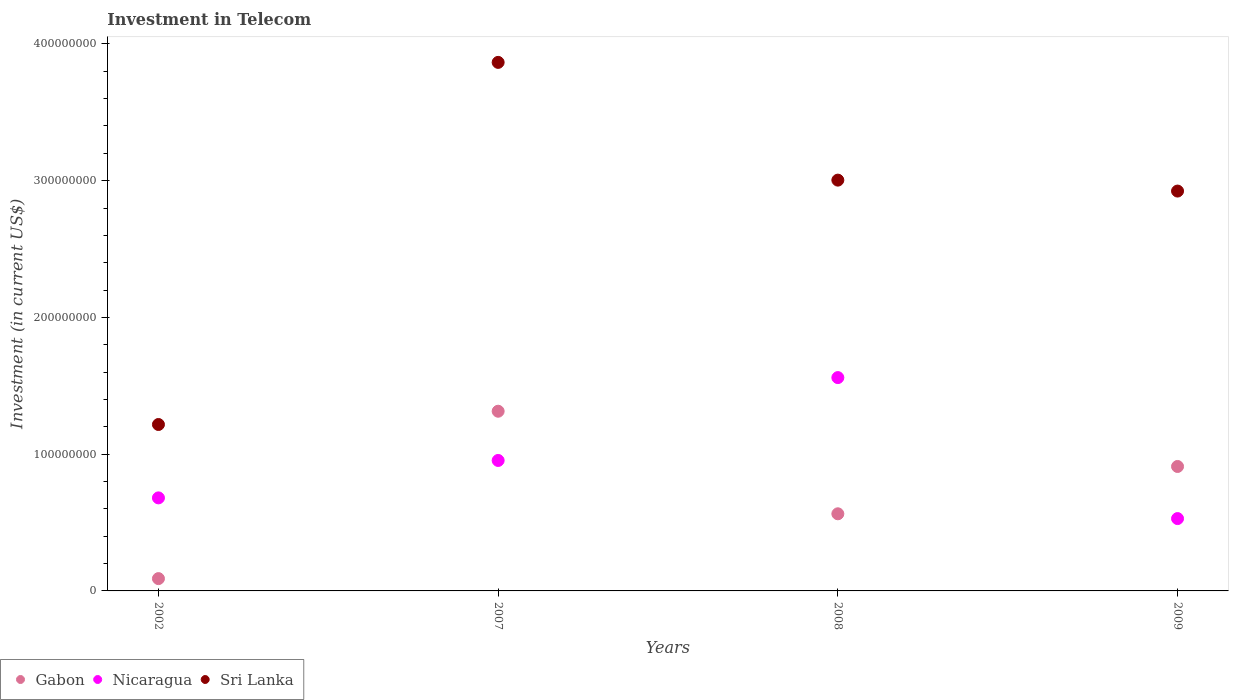How many different coloured dotlines are there?
Give a very brief answer. 3. Is the number of dotlines equal to the number of legend labels?
Your response must be concise. Yes. What is the amount invested in telecom in Gabon in 2009?
Provide a short and direct response. 9.10e+07. Across all years, what is the maximum amount invested in telecom in Sri Lanka?
Give a very brief answer. 3.86e+08. Across all years, what is the minimum amount invested in telecom in Gabon?
Your answer should be very brief. 9.00e+06. In which year was the amount invested in telecom in Sri Lanka maximum?
Offer a terse response. 2007. In which year was the amount invested in telecom in Nicaragua minimum?
Your answer should be very brief. 2009. What is the total amount invested in telecom in Sri Lanka in the graph?
Give a very brief answer. 1.10e+09. What is the difference between the amount invested in telecom in Nicaragua in 2008 and that in 2009?
Provide a succinct answer. 1.03e+08. What is the difference between the amount invested in telecom in Sri Lanka in 2007 and the amount invested in telecom in Gabon in 2008?
Keep it short and to the point. 3.30e+08. What is the average amount invested in telecom in Gabon per year?
Provide a short and direct response. 7.20e+07. In the year 2007, what is the difference between the amount invested in telecom in Gabon and amount invested in telecom in Sri Lanka?
Keep it short and to the point. -2.55e+08. What is the ratio of the amount invested in telecom in Nicaragua in 2002 to that in 2009?
Your response must be concise. 1.29. Is the amount invested in telecom in Nicaragua in 2007 less than that in 2009?
Your response must be concise. No. What is the difference between the highest and the second highest amount invested in telecom in Sri Lanka?
Offer a very short reply. 8.61e+07. What is the difference between the highest and the lowest amount invested in telecom in Sri Lanka?
Your answer should be compact. 2.65e+08. In how many years, is the amount invested in telecom in Gabon greater than the average amount invested in telecom in Gabon taken over all years?
Offer a very short reply. 2. Is the sum of the amount invested in telecom in Sri Lanka in 2002 and 2008 greater than the maximum amount invested in telecom in Nicaragua across all years?
Provide a short and direct response. Yes. Is the amount invested in telecom in Nicaragua strictly greater than the amount invested in telecom in Sri Lanka over the years?
Ensure brevity in your answer.  No. Is the amount invested in telecom in Nicaragua strictly less than the amount invested in telecom in Sri Lanka over the years?
Your answer should be compact. Yes. How many dotlines are there?
Make the answer very short. 3. How many years are there in the graph?
Give a very brief answer. 4. What is the difference between two consecutive major ticks on the Y-axis?
Make the answer very short. 1.00e+08. Where does the legend appear in the graph?
Offer a terse response. Bottom left. What is the title of the graph?
Offer a very short reply. Investment in Telecom. Does "Hungary" appear as one of the legend labels in the graph?
Your answer should be very brief. No. What is the label or title of the X-axis?
Your response must be concise. Years. What is the label or title of the Y-axis?
Ensure brevity in your answer.  Investment (in current US$). What is the Investment (in current US$) of Gabon in 2002?
Give a very brief answer. 9.00e+06. What is the Investment (in current US$) of Nicaragua in 2002?
Provide a succinct answer. 6.80e+07. What is the Investment (in current US$) in Sri Lanka in 2002?
Ensure brevity in your answer.  1.22e+08. What is the Investment (in current US$) of Gabon in 2007?
Keep it short and to the point. 1.31e+08. What is the Investment (in current US$) of Nicaragua in 2007?
Provide a short and direct response. 9.54e+07. What is the Investment (in current US$) of Sri Lanka in 2007?
Keep it short and to the point. 3.86e+08. What is the Investment (in current US$) in Gabon in 2008?
Provide a succinct answer. 5.64e+07. What is the Investment (in current US$) in Nicaragua in 2008?
Your response must be concise. 1.56e+08. What is the Investment (in current US$) in Sri Lanka in 2008?
Make the answer very short. 3.00e+08. What is the Investment (in current US$) of Gabon in 2009?
Keep it short and to the point. 9.10e+07. What is the Investment (in current US$) of Nicaragua in 2009?
Provide a short and direct response. 5.29e+07. What is the Investment (in current US$) of Sri Lanka in 2009?
Your answer should be very brief. 2.92e+08. Across all years, what is the maximum Investment (in current US$) in Gabon?
Make the answer very short. 1.31e+08. Across all years, what is the maximum Investment (in current US$) of Nicaragua?
Give a very brief answer. 1.56e+08. Across all years, what is the maximum Investment (in current US$) of Sri Lanka?
Keep it short and to the point. 3.86e+08. Across all years, what is the minimum Investment (in current US$) in Gabon?
Provide a short and direct response. 9.00e+06. Across all years, what is the minimum Investment (in current US$) in Nicaragua?
Ensure brevity in your answer.  5.29e+07. Across all years, what is the minimum Investment (in current US$) in Sri Lanka?
Your answer should be very brief. 1.22e+08. What is the total Investment (in current US$) of Gabon in the graph?
Provide a short and direct response. 2.88e+08. What is the total Investment (in current US$) of Nicaragua in the graph?
Offer a very short reply. 3.72e+08. What is the total Investment (in current US$) in Sri Lanka in the graph?
Give a very brief answer. 1.10e+09. What is the difference between the Investment (in current US$) in Gabon in 2002 and that in 2007?
Provide a short and direct response. -1.22e+08. What is the difference between the Investment (in current US$) of Nicaragua in 2002 and that in 2007?
Ensure brevity in your answer.  -2.74e+07. What is the difference between the Investment (in current US$) of Sri Lanka in 2002 and that in 2007?
Your answer should be very brief. -2.65e+08. What is the difference between the Investment (in current US$) in Gabon in 2002 and that in 2008?
Your answer should be very brief. -4.74e+07. What is the difference between the Investment (in current US$) of Nicaragua in 2002 and that in 2008?
Ensure brevity in your answer.  -8.80e+07. What is the difference between the Investment (in current US$) in Sri Lanka in 2002 and that in 2008?
Make the answer very short. -1.79e+08. What is the difference between the Investment (in current US$) of Gabon in 2002 and that in 2009?
Your answer should be compact. -8.20e+07. What is the difference between the Investment (in current US$) of Nicaragua in 2002 and that in 2009?
Your answer should be very brief. 1.51e+07. What is the difference between the Investment (in current US$) in Sri Lanka in 2002 and that in 2009?
Your answer should be compact. -1.71e+08. What is the difference between the Investment (in current US$) of Gabon in 2007 and that in 2008?
Offer a very short reply. 7.50e+07. What is the difference between the Investment (in current US$) in Nicaragua in 2007 and that in 2008?
Offer a terse response. -6.06e+07. What is the difference between the Investment (in current US$) in Sri Lanka in 2007 and that in 2008?
Keep it short and to the point. 8.61e+07. What is the difference between the Investment (in current US$) in Gabon in 2007 and that in 2009?
Offer a very short reply. 4.04e+07. What is the difference between the Investment (in current US$) of Nicaragua in 2007 and that in 2009?
Offer a very short reply. 4.25e+07. What is the difference between the Investment (in current US$) of Sri Lanka in 2007 and that in 2009?
Provide a succinct answer. 9.41e+07. What is the difference between the Investment (in current US$) in Gabon in 2008 and that in 2009?
Provide a succinct answer. -3.46e+07. What is the difference between the Investment (in current US$) of Nicaragua in 2008 and that in 2009?
Make the answer very short. 1.03e+08. What is the difference between the Investment (in current US$) in Sri Lanka in 2008 and that in 2009?
Your answer should be very brief. 8.00e+06. What is the difference between the Investment (in current US$) in Gabon in 2002 and the Investment (in current US$) in Nicaragua in 2007?
Offer a very short reply. -8.64e+07. What is the difference between the Investment (in current US$) in Gabon in 2002 and the Investment (in current US$) in Sri Lanka in 2007?
Ensure brevity in your answer.  -3.78e+08. What is the difference between the Investment (in current US$) of Nicaragua in 2002 and the Investment (in current US$) of Sri Lanka in 2007?
Offer a very short reply. -3.18e+08. What is the difference between the Investment (in current US$) in Gabon in 2002 and the Investment (in current US$) in Nicaragua in 2008?
Give a very brief answer. -1.47e+08. What is the difference between the Investment (in current US$) of Gabon in 2002 and the Investment (in current US$) of Sri Lanka in 2008?
Your answer should be very brief. -2.91e+08. What is the difference between the Investment (in current US$) of Nicaragua in 2002 and the Investment (in current US$) of Sri Lanka in 2008?
Provide a succinct answer. -2.32e+08. What is the difference between the Investment (in current US$) in Gabon in 2002 and the Investment (in current US$) in Nicaragua in 2009?
Ensure brevity in your answer.  -4.39e+07. What is the difference between the Investment (in current US$) of Gabon in 2002 and the Investment (in current US$) of Sri Lanka in 2009?
Provide a short and direct response. -2.83e+08. What is the difference between the Investment (in current US$) in Nicaragua in 2002 and the Investment (in current US$) in Sri Lanka in 2009?
Keep it short and to the point. -2.24e+08. What is the difference between the Investment (in current US$) of Gabon in 2007 and the Investment (in current US$) of Nicaragua in 2008?
Your response must be concise. -2.46e+07. What is the difference between the Investment (in current US$) in Gabon in 2007 and the Investment (in current US$) in Sri Lanka in 2008?
Keep it short and to the point. -1.69e+08. What is the difference between the Investment (in current US$) in Nicaragua in 2007 and the Investment (in current US$) in Sri Lanka in 2008?
Your response must be concise. -2.05e+08. What is the difference between the Investment (in current US$) of Gabon in 2007 and the Investment (in current US$) of Nicaragua in 2009?
Your response must be concise. 7.85e+07. What is the difference between the Investment (in current US$) of Gabon in 2007 and the Investment (in current US$) of Sri Lanka in 2009?
Make the answer very short. -1.61e+08. What is the difference between the Investment (in current US$) in Nicaragua in 2007 and the Investment (in current US$) in Sri Lanka in 2009?
Your answer should be compact. -1.97e+08. What is the difference between the Investment (in current US$) of Gabon in 2008 and the Investment (in current US$) of Nicaragua in 2009?
Offer a very short reply. 3.50e+06. What is the difference between the Investment (in current US$) of Gabon in 2008 and the Investment (in current US$) of Sri Lanka in 2009?
Offer a very short reply. -2.36e+08. What is the difference between the Investment (in current US$) in Nicaragua in 2008 and the Investment (in current US$) in Sri Lanka in 2009?
Offer a terse response. -1.36e+08. What is the average Investment (in current US$) of Gabon per year?
Offer a terse response. 7.20e+07. What is the average Investment (in current US$) in Nicaragua per year?
Give a very brief answer. 9.31e+07. What is the average Investment (in current US$) of Sri Lanka per year?
Your answer should be very brief. 2.75e+08. In the year 2002, what is the difference between the Investment (in current US$) of Gabon and Investment (in current US$) of Nicaragua?
Your response must be concise. -5.90e+07. In the year 2002, what is the difference between the Investment (in current US$) in Gabon and Investment (in current US$) in Sri Lanka?
Your answer should be compact. -1.13e+08. In the year 2002, what is the difference between the Investment (in current US$) of Nicaragua and Investment (in current US$) of Sri Lanka?
Ensure brevity in your answer.  -5.37e+07. In the year 2007, what is the difference between the Investment (in current US$) in Gabon and Investment (in current US$) in Nicaragua?
Your response must be concise. 3.60e+07. In the year 2007, what is the difference between the Investment (in current US$) of Gabon and Investment (in current US$) of Sri Lanka?
Offer a terse response. -2.55e+08. In the year 2007, what is the difference between the Investment (in current US$) in Nicaragua and Investment (in current US$) in Sri Lanka?
Offer a very short reply. -2.91e+08. In the year 2008, what is the difference between the Investment (in current US$) in Gabon and Investment (in current US$) in Nicaragua?
Provide a short and direct response. -9.96e+07. In the year 2008, what is the difference between the Investment (in current US$) of Gabon and Investment (in current US$) of Sri Lanka?
Give a very brief answer. -2.44e+08. In the year 2008, what is the difference between the Investment (in current US$) of Nicaragua and Investment (in current US$) of Sri Lanka?
Make the answer very short. -1.44e+08. In the year 2009, what is the difference between the Investment (in current US$) in Gabon and Investment (in current US$) in Nicaragua?
Ensure brevity in your answer.  3.81e+07. In the year 2009, what is the difference between the Investment (in current US$) of Gabon and Investment (in current US$) of Sri Lanka?
Provide a succinct answer. -2.01e+08. In the year 2009, what is the difference between the Investment (in current US$) in Nicaragua and Investment (in current US$) in Sri Lanka?
Offer a very short reply. -2.40e+08. What is the ratio of the Investment (in current US$) of Gabon in 2002 to that in 2007?
Offer a terse response. 0.07. What is the ratio of the Investment (in current US$) in Nicaragua in 2002 to that in 2007?
Your answer should be very brief. 0.71. What is the ratio of the Investment (in current US$) in Sri Lanka in 2002 to that in 2007?
Your answer should be very brief. 0.31. What is the ratio of the Investment (in current US$) of Gabon in 2002 to that in 2008?
Make the answer very short. 0.16. What is the ratio of the Investment (in current US$) in Nicaragua in 2002 to that in 2008?
Your response must be concise. 0.44. What is the ratio of the Investment (in current US$) of Sri Lanka in 2002 to that in 2008?
Your answer should be very brief. 0.41. What is the ratio of the Investment (in current US$) of Gabon in 2002 to that in 2009?
Offer a terse response. 0.1. What is the ratio of the Investment (in current US$) of Nicaragua in 2002 to that in 2009?
Make the answer very short. 1.29. What is the ratio of the Investment (in current US$) of Sri Lanka in 2002 to that in 2009?
Keep it short and to the point. 0.42. What is the ratio of the Investment (in current US$) in Gabon in 2007 to that in 2008?
Keep it short and to the point. 2.33. What is the ratio of the Investment (in current US$) in Nicaragua in 2007 to that in 2008?
Your response must be concise. 0.61. What is the ratio of the Investment (in current US$) in Sri Lanka in 2007 to that in 2008?
Your answer should be compact. 1.29. What is the ratio of the Investment (in current US$) in Gabon in 2007 to that in 2009?
Your response must be concise. 1.44. What is the ratio of the Investment (in current US$) of Nicaragua in 2007 to that in 2009?
Make the answer very short. 1.8. What is the ratio of the Investment (in current US$) in Sri Lanka in 2007 to that in 2009?
Provide a short and direct response. 1.32. What is the ratio of the Investment (in current US$) of Gabon in 2008 to that in 2009?
Your answer should be compact. 0.62. What is the ratio of the Investment (in current US$) of Nicaragua in 2008 to that in 2009?
Give a very brief answer. 2.95. What is the ratio of the Investment (in current US$) in Sri Lanka in 2008 to that in 2009?
Your answer should be compact. 1.03. What is the difference between the highest and the second highest Investment (in current US$) of Gabon?
Provide a succinct answer. 4.04e+07. What is the difference between the highest and the second highest Investment (in current US$) in Nicaragua?
Keep it short and to the point. 6.06e+07. What is the difference between the highest and the second highest Investment (in current US$) of Sri Lanka?
Make the answer very short. 8.61e+07. What is the difference between the highest and the lowest Investment (in current US$) in Gabon?
Provide a short and direct response. 1.22e+08. What is the difference between the highest and the lowest Investment (in current US$) of Nicaragua?
Your response must be concise. 1.03e+08. What is the difference between the highest and the lowest Investment (in current US$) in Sri Lanka?
Make the answer very short. 2.65e+08. 